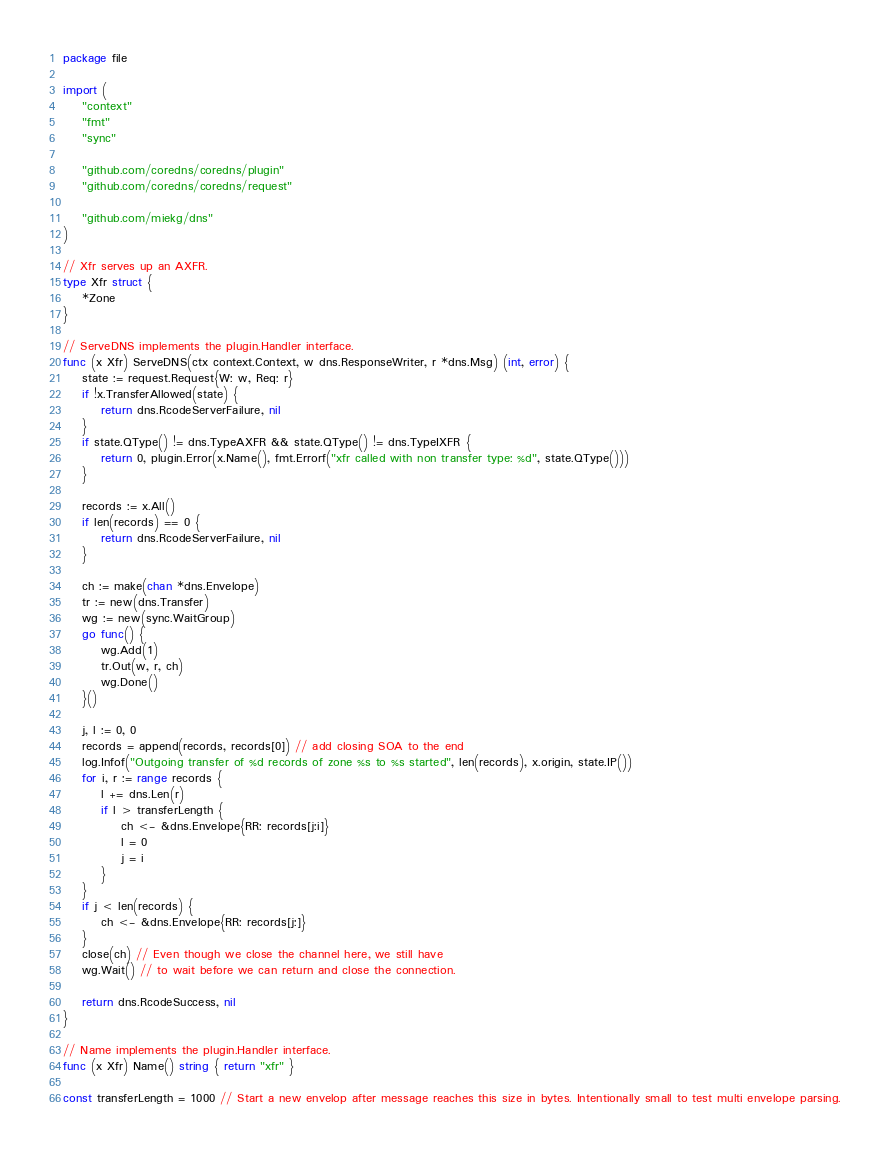Convert code to text. <code><loc_0><loc_0><loc_500><loc_500><_Go_>package file

import (
	"context"
	"fmt"
	"sync"

	"github.com/coredns/coredns/plugin"
	"github.com/coredns/coredns/request"

	"github.com/miekg/dns"
)

// Xfr serves up an AXFR.
type Xfr struct {
	*Zone
}

// ServeDNS implements the plugin.Handler interface.
func (x Xfr) ServeDNS(ctx context.Context, w dns.ResponseWriter, r *dns.Msg) (int, error) {
	state := request.Request{W: w, Req: r}
	if !x.TransferAllowed(state) {
		return dns.RcodeServerFailure, nil
	}
	if state.QType() != dns.TypeAXFR && state.QType() != dns.TypeIXFR {
		return 0, plugin.Error(x.Name(), fmt.Errorf("xfr called with non transfer type: %d", state.QType()))
	}

	records := x.All()
	if len(records) == 0 {
		return dns.RcodeServerFailure, nil
	}

	ch := make(chan *dns.Envelope)
	tr := new(dns.Transfer)
	wg := new(sync.WaitGroup)
	go func() {
		wg.Add(1)
		tr.Out(w, r, ch)
		wg.Done()
	}()

	j, l := 0, 0
	records = append(records, records[0]) // add closing SOA to the end
	log.Infof("Outgoing transfer of %d records of zone %s to %s started", len(records), x.origin, state.IP())
	for i, r := range records {
		l += dns.Len(r)
		if l > transferLength {
			ch <- &dns.Envelope{RR: records[j:i]}
			l = 0
			j = i
		}
	}
	if j < len(records) {
		ch <- &dns.Envelope{RR: records[j:]}
	}
	close(ch) // Even though we close the channel here, we still have
	wg.Wait() // to wait before we can return and close the connection.

	return dns.RcodeSuccess, nil
}

// Name implements the plugin.Handler interface.
func (x Xfr) Name() string { return "xfr" }

const transferLength = 1000 // Start a new envelop after message reaches this size in bytes. Intentionally small to test multi envelope parsing.
</code> 